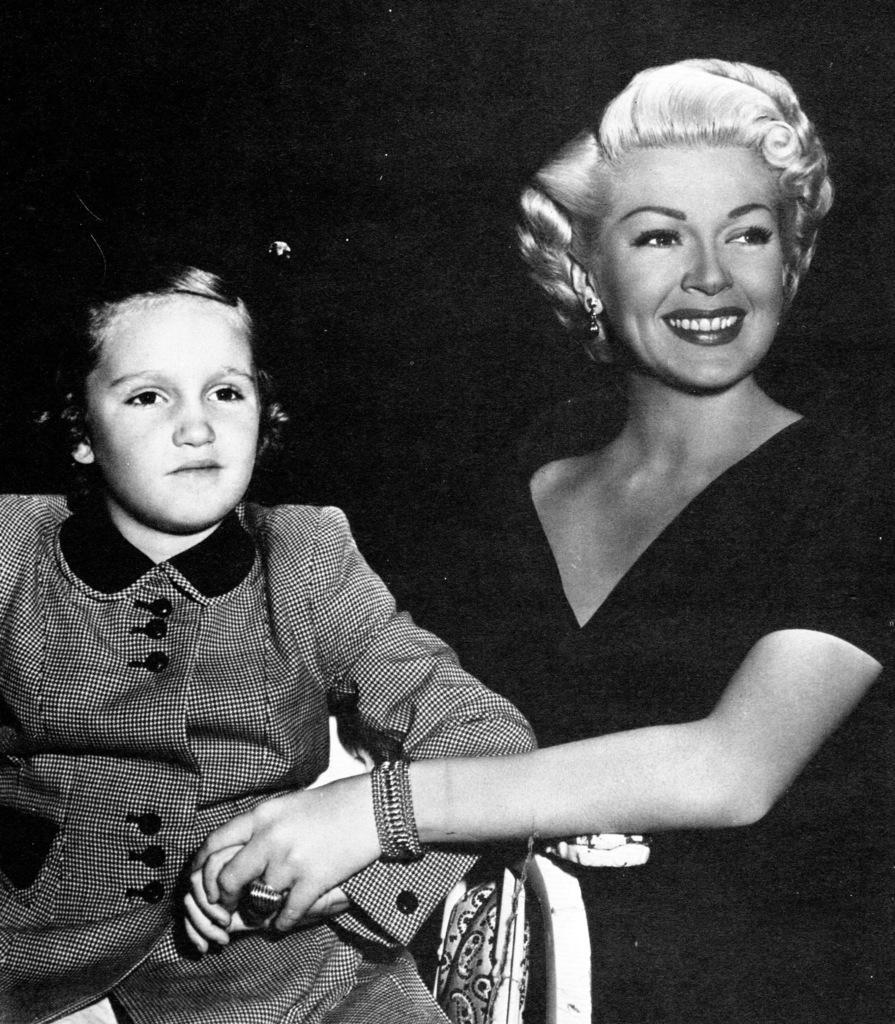In one or two sentences, can you explain what this image depicts? In this black and white picture a woman is standing beside the car having a person sitting on it. Woman is wearing a bangle and a ring to her hand. She is holding the hand of this person. She is smiling. 